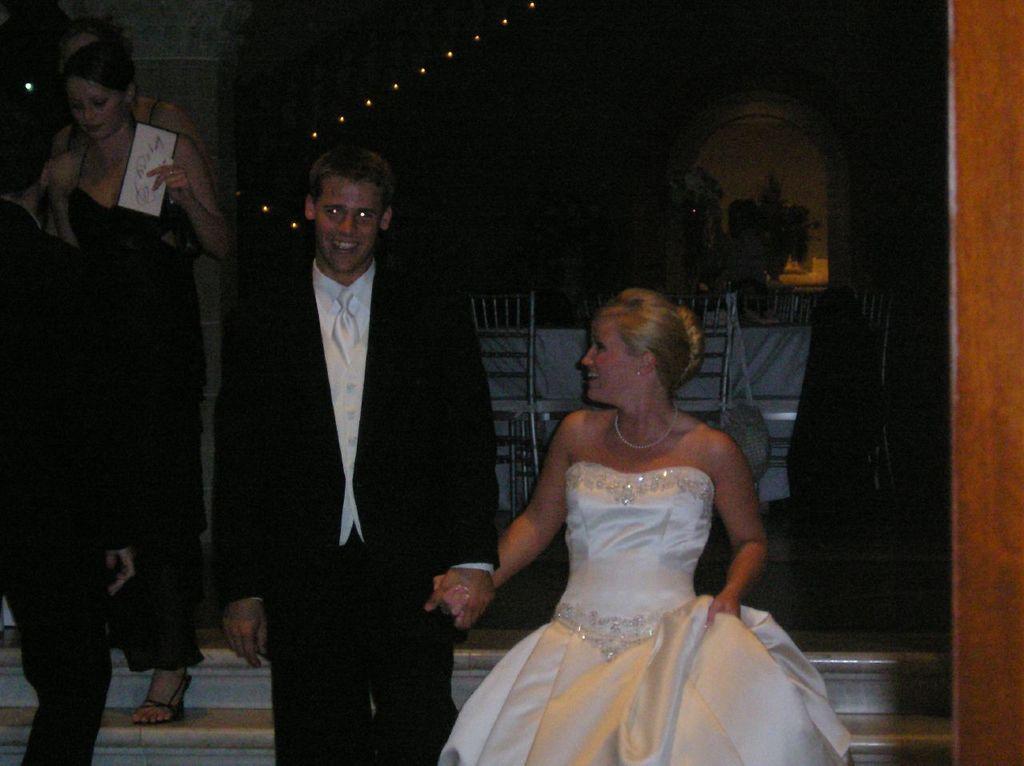Could you give a brief overview of what you see in this image? In this image I can see there are few persons getting down from steps and background dark in the background there are some lights, flower pots and plants visible 